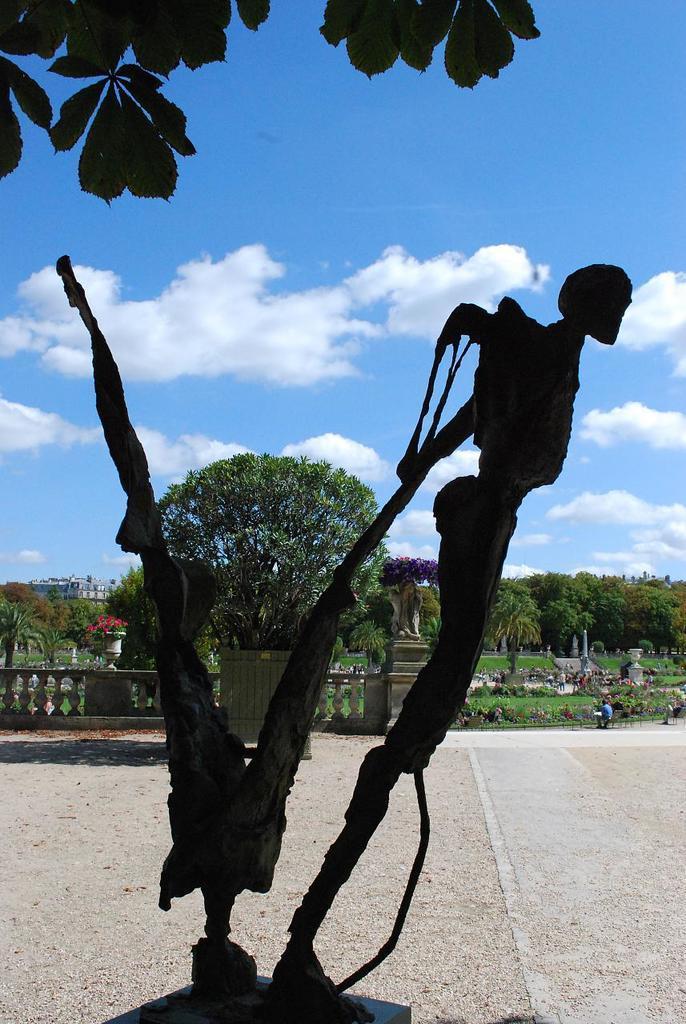Describe this image in one or two sentences. In this image there is one monument at bottom of this image and there are some trees in the background and there is a wall at left side of this image and there are some persons standing at right side of this image. There is a cloudy sky at top of this image and there is one tree at top left corner of this image. 